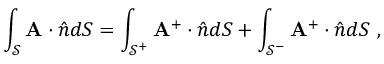Convert formula to latex. <formula><loc_0><loc_0><loc_500><loc_500>\int _ { \mathcal { S } } A \cdot \hat { n } d S = \int _ { \mathcal { S } ^ { + } } A ^ { + } \cdot \hat { n } d S + \int _ { \mathcal { S } ^ { - } } A ^ { + } \cdot \hat { n } d S ,</formula> 